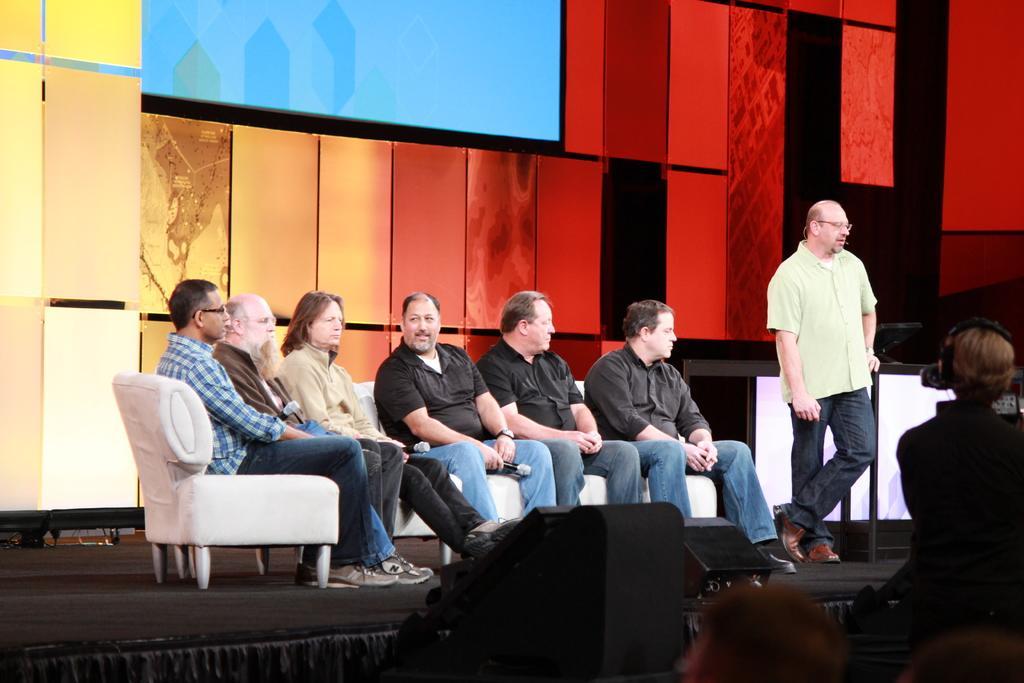Could you give a brief overview of what you see in this image? In this image i can see few people sitting on a couch, at the back ground i can see a glass wall and a screen. 